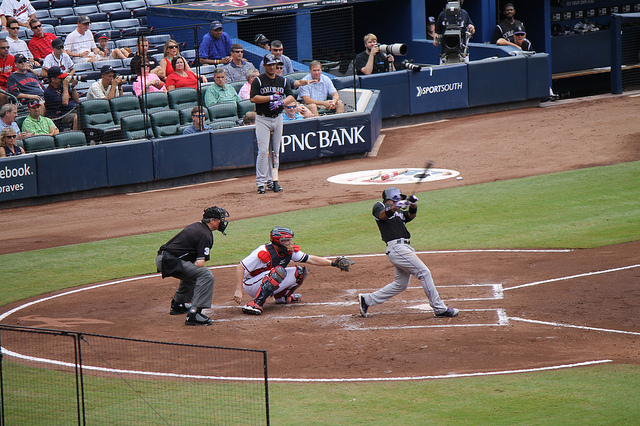What details can you provide about the equipment the players are using? In this baseball game, the players use several pieces of equipment. The batter is holding a baseball bat, usually made of wood or a composite metal designed to hit pitches thrown by the pitcher. The catcher, crouching behind home plate, wears protective gear that includes a helmet with a face mask, chest protector, and leg guards to prevent injury from foul balls and missed pitches. The pitcher's glove is visible, which is larger than the infielder's gloves to help conceal the ball and the type of pitch being thrown. The umpire also has protective gear and is responsible for officiating the game, including calling balls, strikes, and outs. 